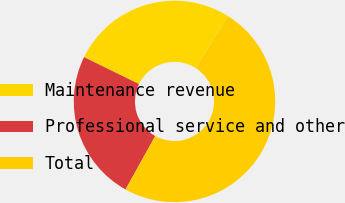<chart> <loc_0><loc_0><loc_500><loc_500><pie_chart><fcel>Maintenance revenue<fcel>Professional service and other<fcel>Total<nl><fcel>26.67%<fcel>24.17%<fcel>49.17%<nl></chart> 